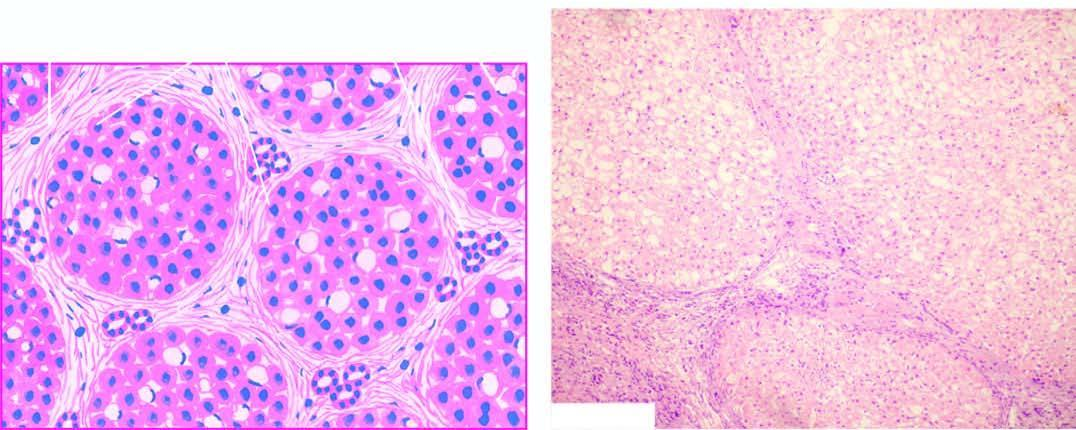s 2 and 3 minimal inflammation and some reactive bile duct proliferation in the septa?
Answer the question using a single word or phrase. No 